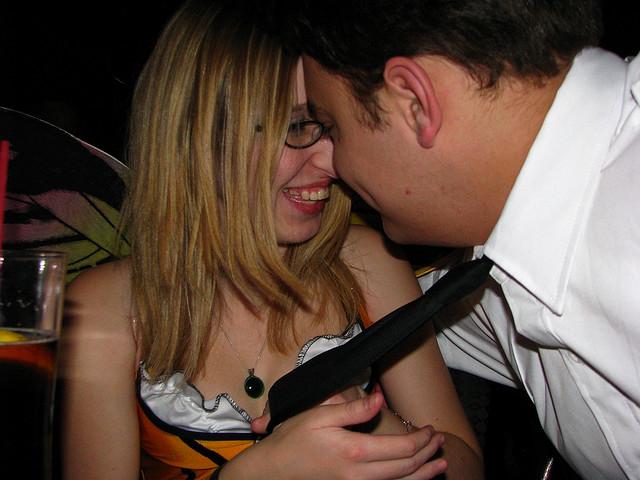Is the man or woman wearing glasses?
Concise answer only. Woman. Is the guy wearing a tie?
Be succinct. Yes. Is the lady talking on the phone?
Answer briefly. No. What is this man shoving into his mouth?
Concise answer only. Nothing. What is covering the woman's eyes?
Concise answer only. Glasses. What pattern dress is she wearing?
Write a very short answer. Striped. Is this man on his cell phone?
Concise answer only. No. Are the two people going home together tonight?
Keep it brief. Yes. What color is the wristband?
Keep it brief. Black. What type of food are they sharing?
Answer briefly. Nothing. Does this woman have blonde hair?
Quick response, please. Yes. What is the man doing in the photo?
Write a very short answer. Kissing. What is the hand moving toward?
Keep it brief. Tie. What print is this woman's dress?
Answer briefly. Striped. Is there anyone else in this picture?
Short answer required. Yes. Is she talking to her mom?
Be succinct. No. Is the girl a brunette?
Be succinct. No. What is the woman holding?
Write a very short answer. Tie. Is this person drunk?
Quick response, please. Yes. What is the condition of the woman's fingernails?
Concise answer only. Short. What color is her shirt?
Be succinct. Orange. What is the girl holding?
Concise answer only. Tie. What dangerous activity is she doing?
Short answer required. Flirting. Do these people look happy?
Answer briefly. Yes. Is the couple smiling?
Concise answer only. Yes. What is on a stick and is being held by a woman?
Give a very brief answer. Tie. What color are the girl's fingernails?
Write a very short answer. Pink. Has he or she had wine?
Write a very short answer. Yes. What color is the woman's hair?
Give a very brief answer. Blonde. What type of necklace does the girl have on?
Short answer required. Black. Is the woman wearing a jacket?
Answer briefly. No. What is the man wearing?
Answer briefly. Shirt and tie. Is this woman married?
Keep it brief. No. Who is wearing a button up shirt?
Quick response, please. Man. What does the woman have on her eyes?
Give a very brief answer. Glasses. Does the girl have straight hair?
Concise answer only. Yes. What is the woman doing?
Write a very short answer. Flirting. How many people are in the photo?
Give a very brief answer. 2. 